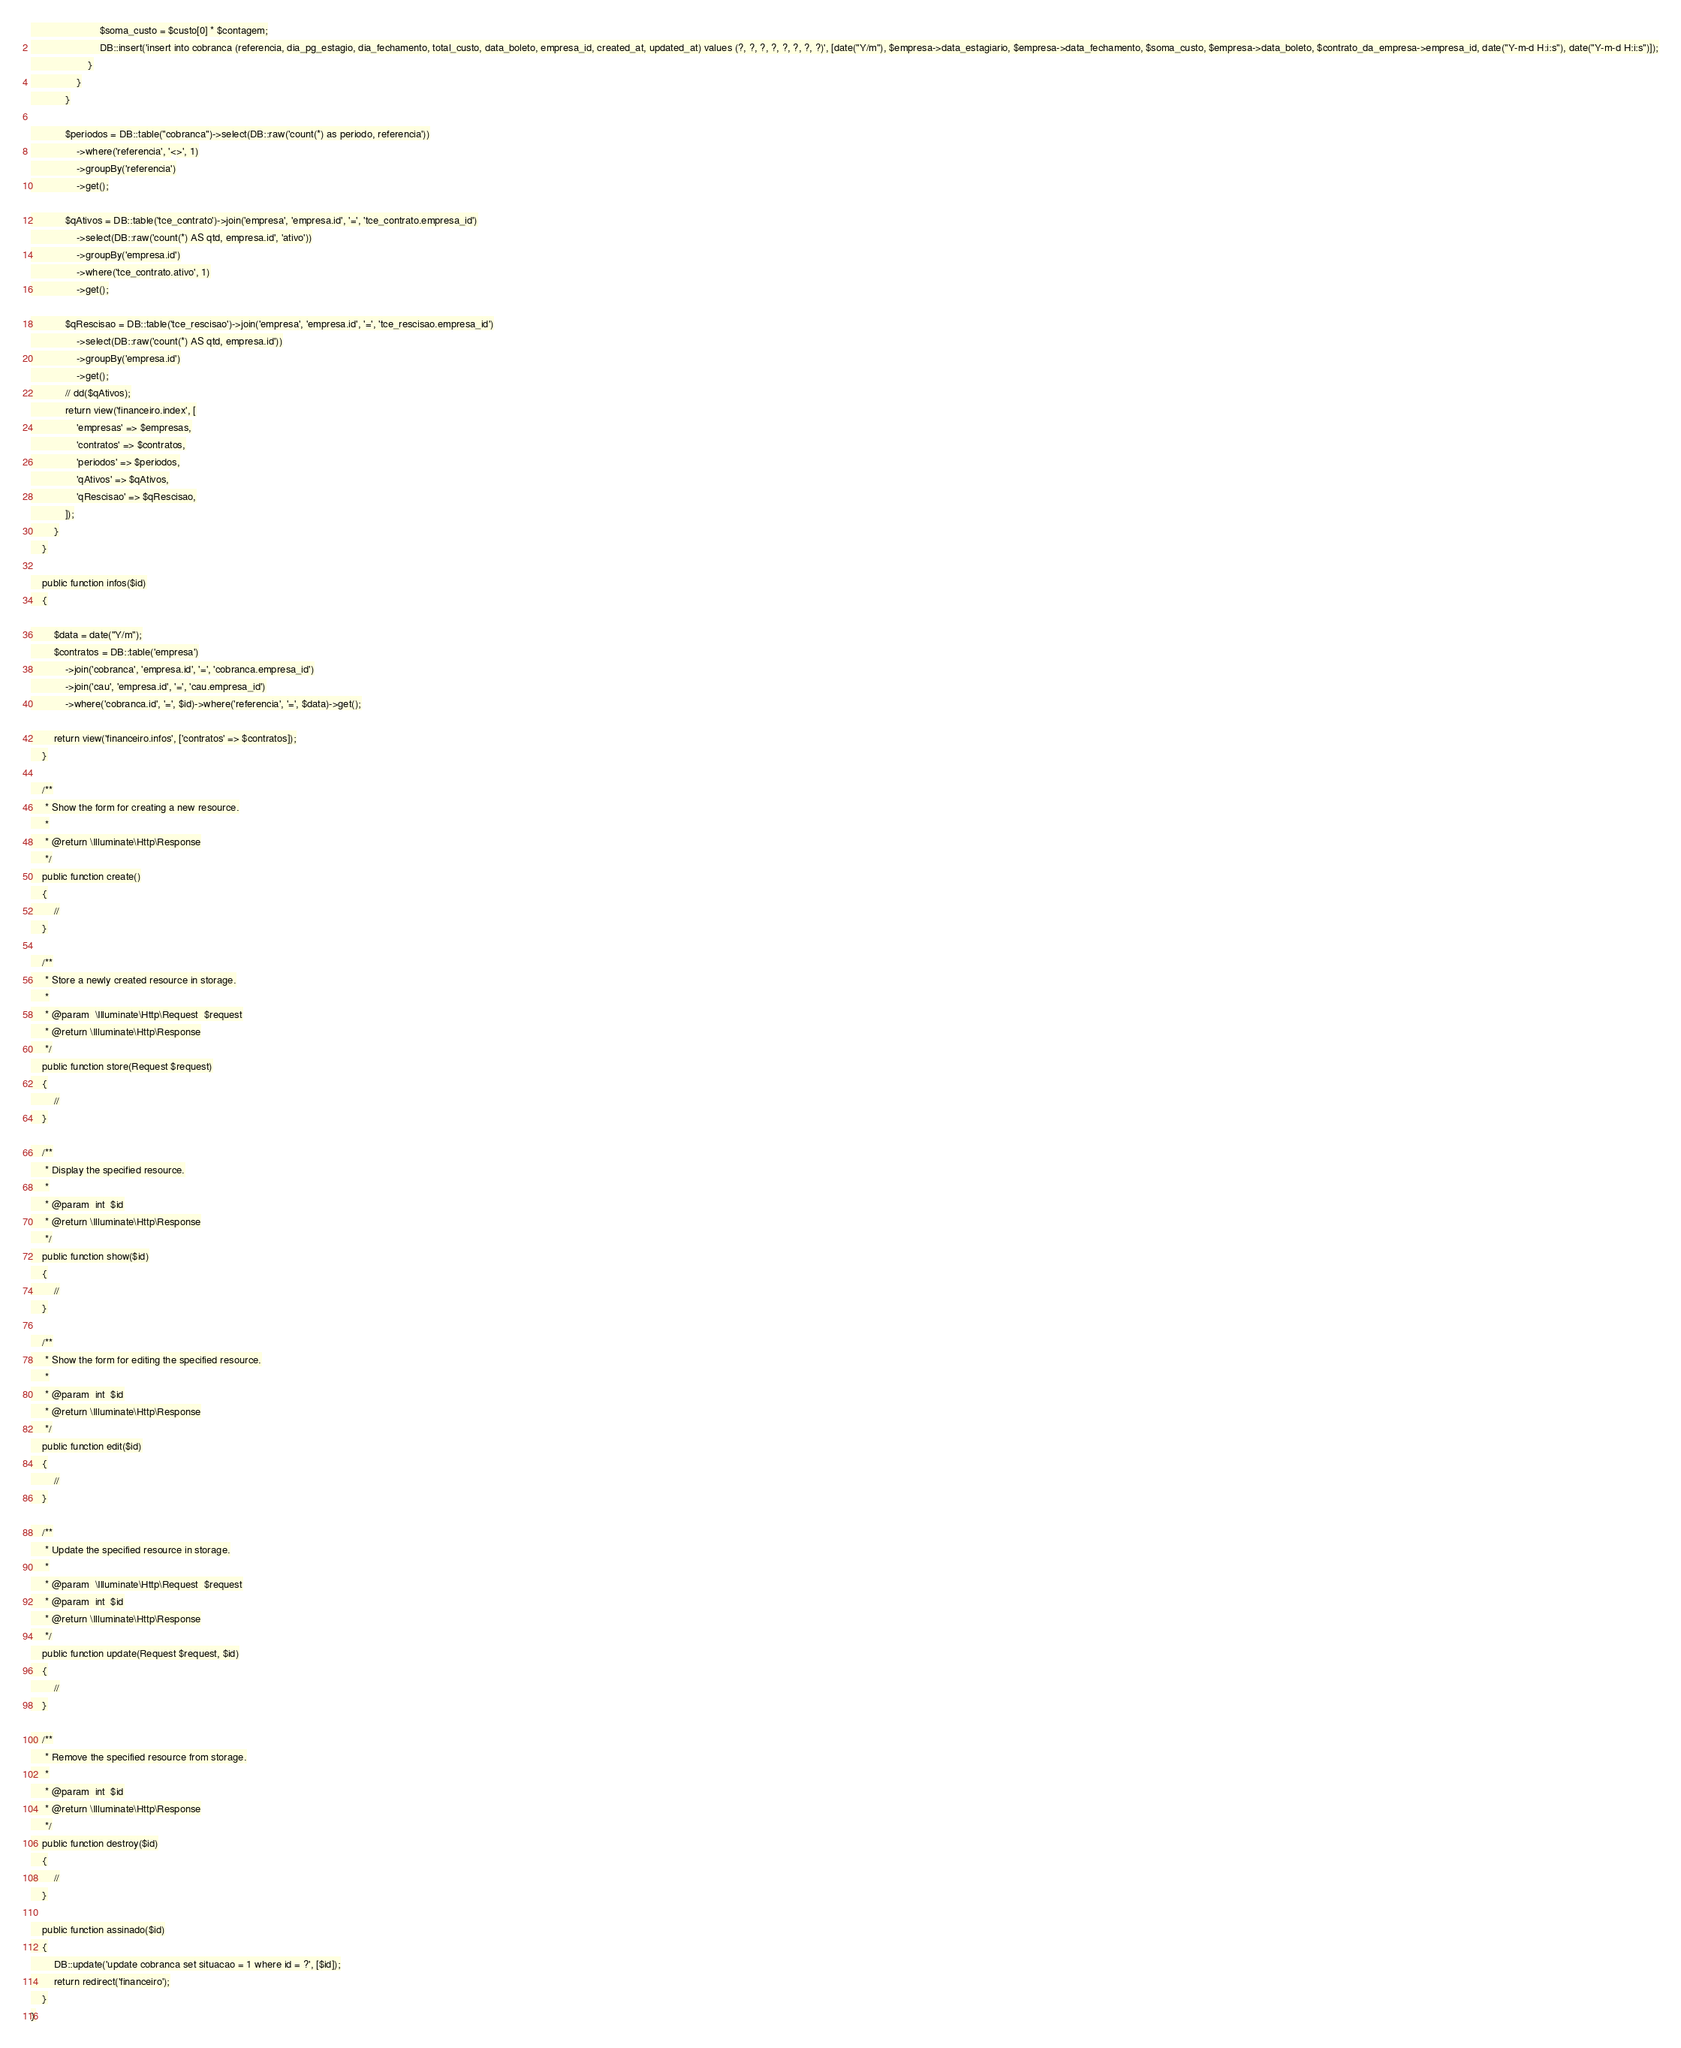Convert code to text. <code><loc_0><loc_0><loc_500><loc_500><_PHP_>                        $soma_custo = $custo[0] * $contagem;
                        DB::insert('insert into cobranca (referencia, dia_pg_estagio, dia_fechamento, total_custo, data_boleto, empresa_id, created_at, updated_at) values (?, ?, ?, ?, ?, ?, ?, ?)', [date("Y/m"), $empresa->data_estagiario, $empresa->data_fechamento, $soma_custo, $empresa->data_boleto, $contrato_da_empresa->empresa_id, date("Y-m-d H:i:s"), date("Y-m-d H:i:s")]);
                    }
                }
            }

            $periodos = DB::table("cobranca")->select(DB::raw('count(*) as periodo, referencia'))
                ->where('referencia', '<>', 1)
                ->groupBy('referencia')
                ->get();

            $qAtivos = DB::table('tce_contrato')->join('empresa', 'empresa.id', '=', 'tce_contrato.empresa_id')
                ->select(DB::raw('count(*) AS qtd, empresa.id', 'ativo'))
                ->groupBy('empresa.id')
                ->where('tce_contrato.ativo', 1)
                ->get();

            $qRescisao = DB::table('tce_rescisao')->join('empresa', 'empresa.id', '=', 'tce_rescisao.empresa_id')
                ->select(DB::raw('count(*) AS qtd, empresa.id'))
                ->groupBy('empresa.id')
                ->get();
            // dd($qAtivos);
            return view('financeiro.index', [
                'empresas' => $empresas,
                'contratos' => $contratos,
                'periodos' => $periodos,
                'qAtivos' => $qAtivos,
                'qRescisao' => $qRescisao,
            ]);
        }
    }

    public function infos($id)
    {

        $data = date("Y/m");
        $contratos = DB::table('empresa')
            ->join('cobranca', 'empresa.id', '=', 'cobranca.empresa_id')
            ->join('cau', 'empresa.id', '=', 'cau.empresa_id')
            ->where('cobranca.id', '=', $id)->where('referencia', '=', $data)->get();

        return view('financeiro.infos', ['contratos' => $contratos]);
    }

    /**
     * Show the form for creating a new resource.
     *
     * @return \Illuminate\Http\Response
     */
    public function create()
    {
        //
    }

    /**
     * Store a newly created resource in storage.
     *
     * @param  \Illuminate\Http\Request  $request
     * @return \Illuminate\Http\Response
     */
    public function store(Request $request)
    {
        //
    }

    /**
     * Display the specified resource.
     *
     * @param  int  $id
     * @return \Illuminate\Http\Response
     */
    public function show($id)
    {
        //
    }

    /**
     * Show the form for editing the specified resource.
     *
     * @param  int  $id
     * @return \Illuminate\Http\Response
     */
    public function edit($id)
    {
        //
    }

    /**
     * Update the specified resource in storage.
     *
     * @param  \Illuminate\Http\Request  $request
     * @param  int  $id
     * @return \Illuminate\Http\Response
     */
    public function update(Request $request, $id)
    {
        //
    }

    /**
     * Remove the specified resource from storage.
     *
     * @param  int  $id
     * @return \Illuminate\Http\Response
     */
    public function destroy($id)
    {
        //
    }

    public function assinado($id)
    {
        DB::update('update cobranca set situacao = 1 where id = ?', [$id]);
        return redirect('financeiro');
    }
}
</code> 